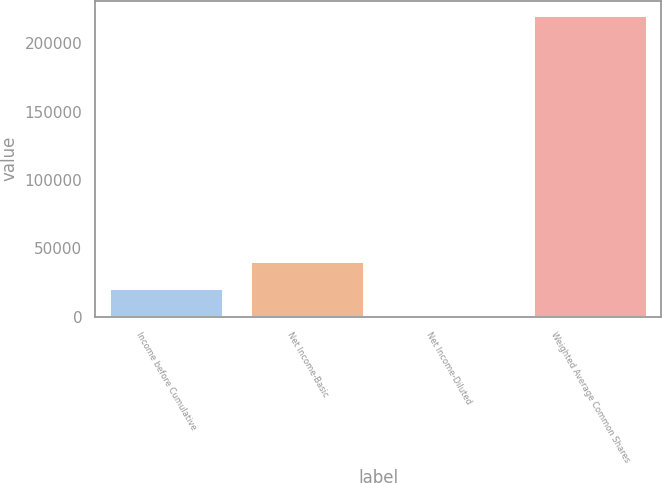Convert chart. <chart><loc_0><loc_0><loc_500><loc_500><bar_chart><fcel>Income before Cumulative<fcel>Net Income-Basic<fcel>Net Income-Diluted<fcel>Weighted Average Common Shares<nl><fcel>20206.9<fcel>40413<fcel>0.76<fcel>220144<nl></chart> 